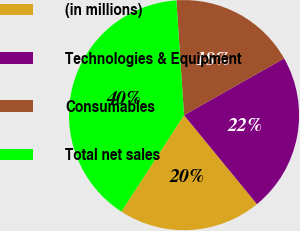Convert chart to OTSL. <chart><loc_0><loc_0><loc_500><loc_500><pie_chart><fcel>(in millions)<fcel>Technologies & Equipment<fcel>Consumables<fcel>Total net sales<nl><fcel>20.09%<fcel>22.28%<fcel>17.85%<fcel>39.77%<nl></chart> 